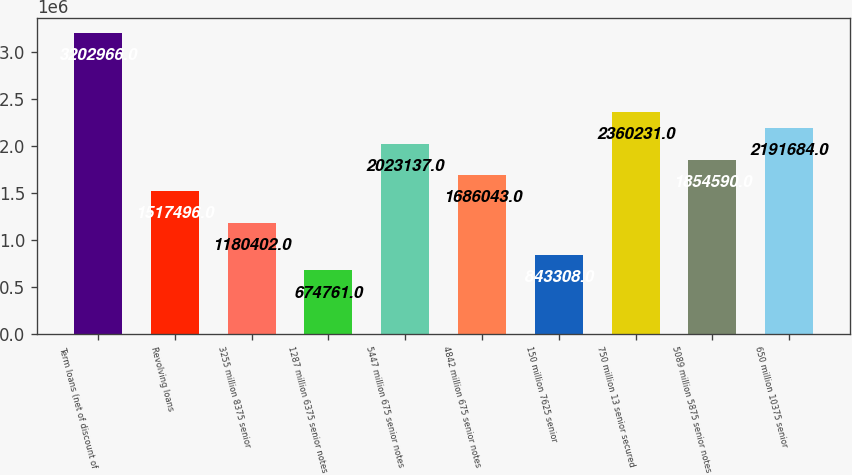<chart> <loc_0><loc_0><loc_500><loc_500><bar_chart><fcel>Term loans (net of discount of<fcel>Revolving loans<fcel>3255 million 8375 senior<fcel>1287 million 6375 senior notes<fcel>5447 million 675 senior notes<fcel>4842 million 675 senior notes<fcel>150 million 7625 senior<fcel>750 million 13 senior secured<fcel>5089 million 5875 senior notes<fcel>650 million 10375 senior<nl><fcel>3.20297e+06<fcel>1.5175e+06<fcel>1.1804e+06<fcel>674761<fcel>2.02314e+06<fcel>1.68604e+06<fcel>843308<fcel>2.36023e+06<fcel>1.85459e+06<fcel>2.19168e+06<nl></chart> 